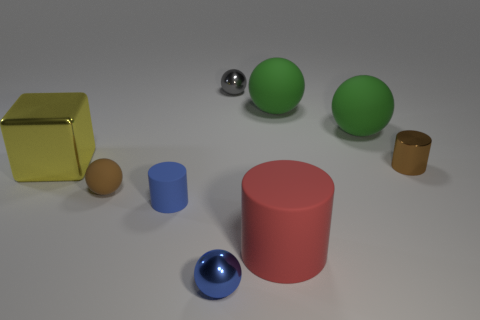Which object seems out of place compared to the others, and why? The metallic sphere appears somewhat out of place compared to the others due to its reflective surface, which stands in contrast to the mostly matte finishes of the other objects. It reflects the environment, making it distinct from the other objects that absorb light. 